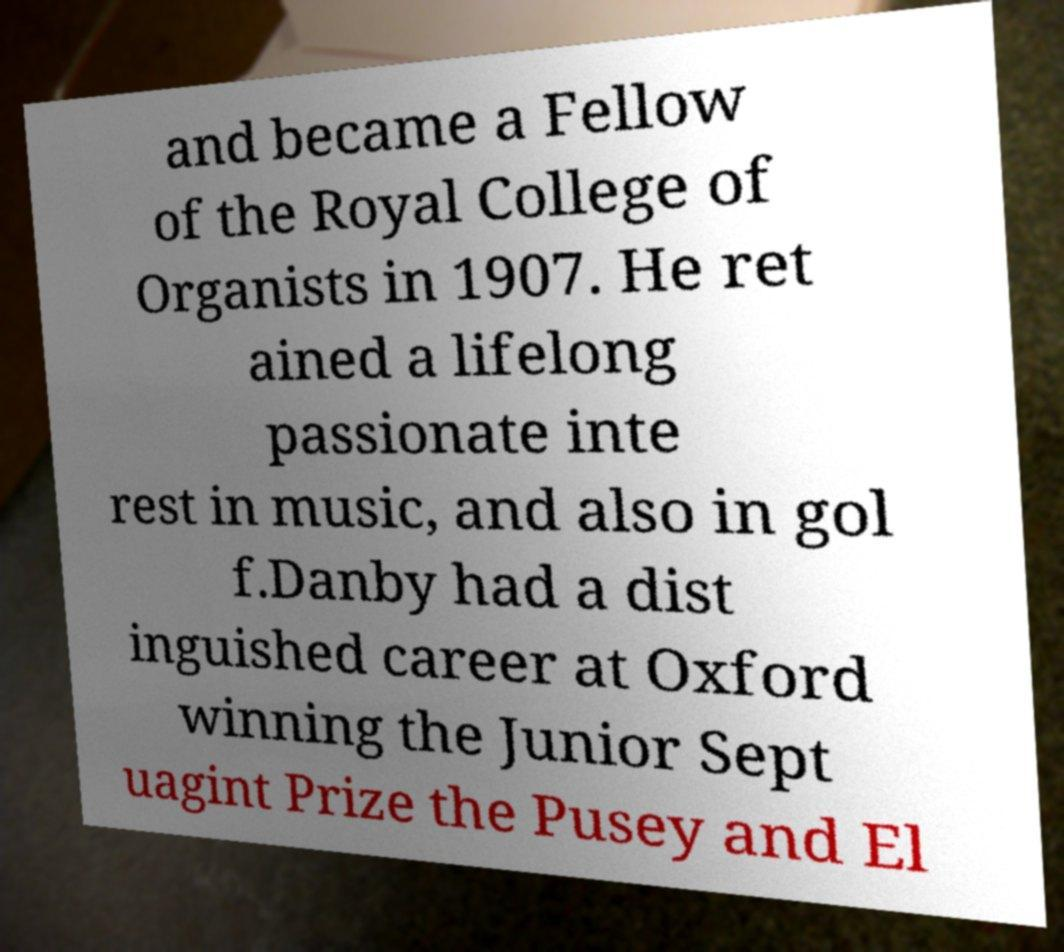Please identify and transcribe the text found in this image. and became a Fellow of the Royal College of Organists in 1907. He ret ained a lifelong passionate inte rest in music, and also in gol f.Danby had a dist inguished career at Oxford winning the Junior Sept uagint Prize the Pusey and El 